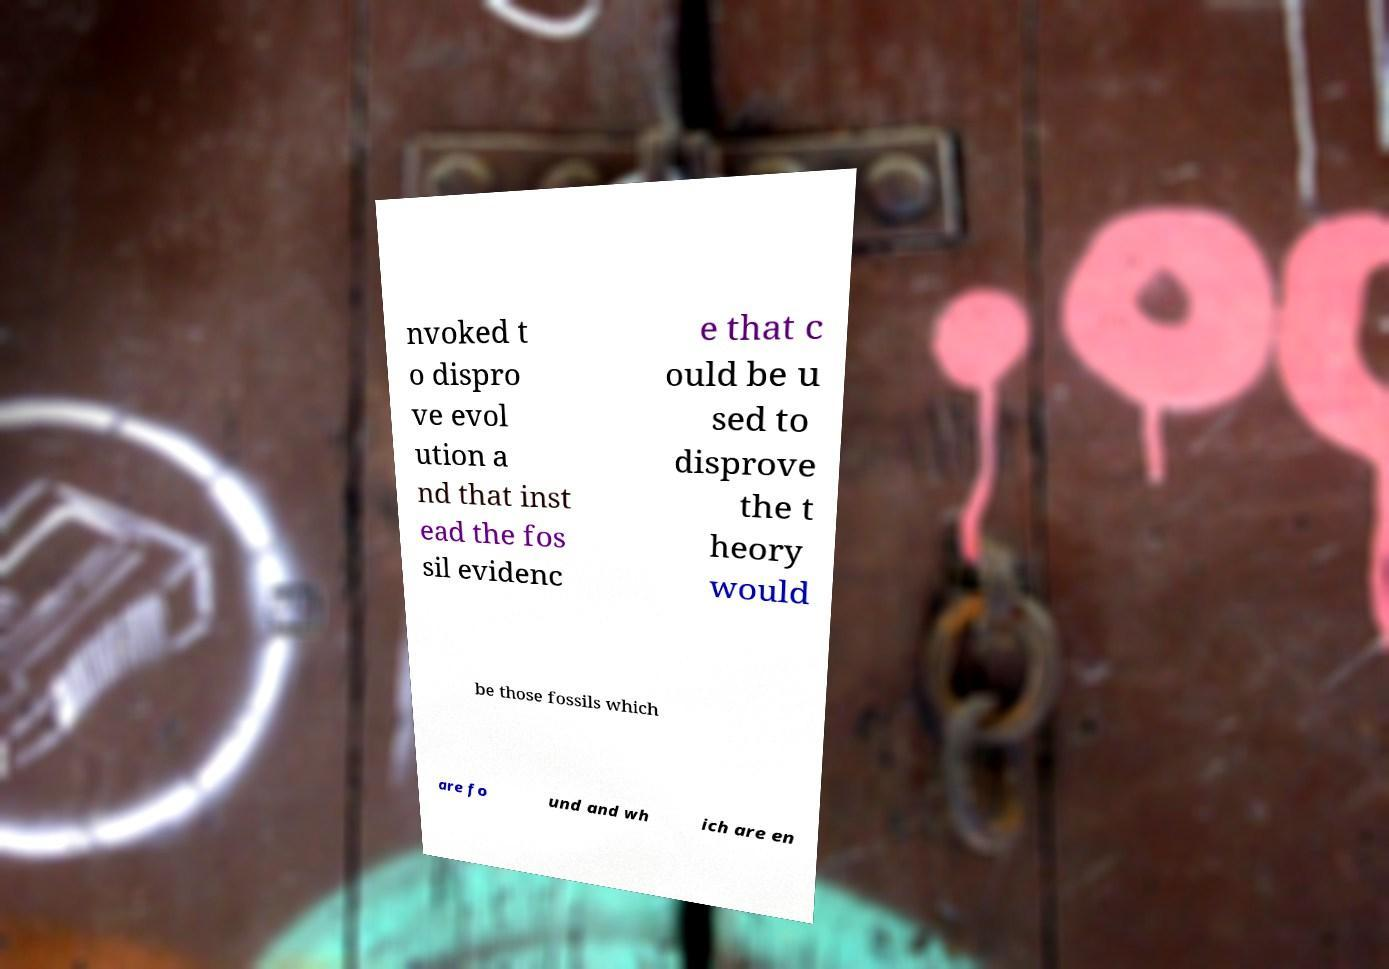Could you assist in decoding the text presented in this image and type it out clearly? nvoked t o dispro ve evol ution a nd that inst ead the fos sil evidenc e that c ould be u sed to disprove the t heory would be those fossils which are fo und and wh ich are en 